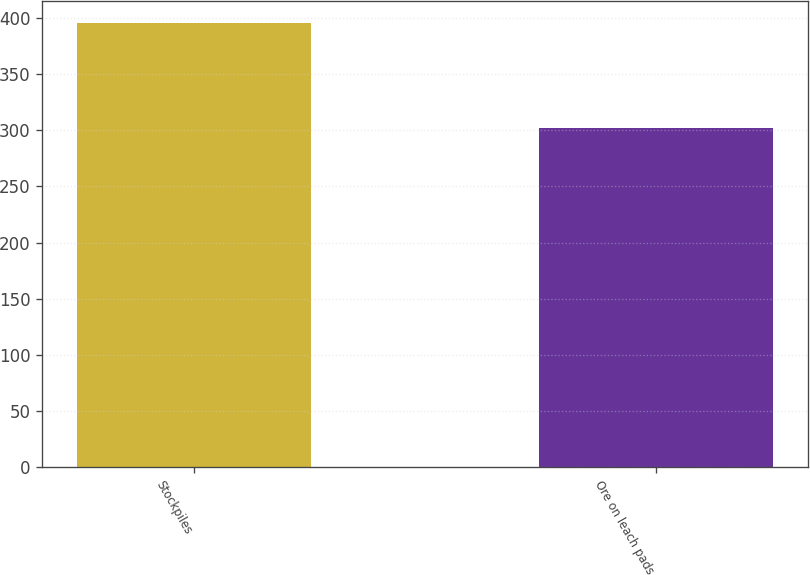Convert chart to OTSL. <chart><loc_0><loc_0><loc_500><loc_500><bar_chart><fcel>Stockpiles<fcel>Ore on leach pads<nl><fcel>395<fcel>302<nl></chart> 